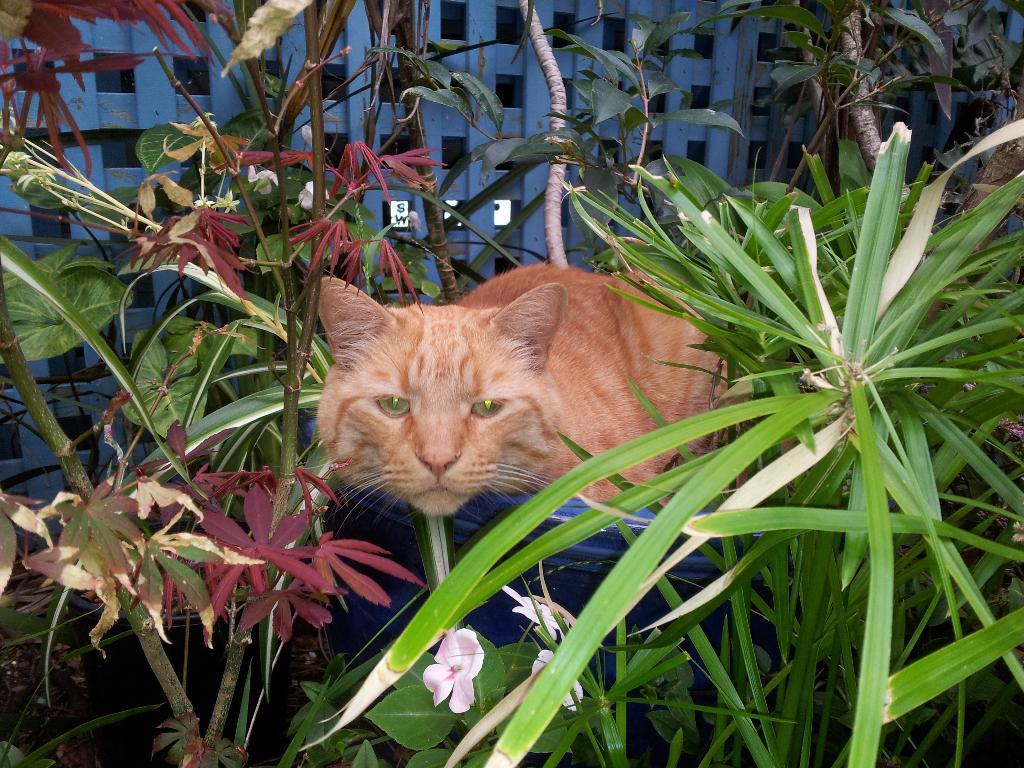What animal is present in the image? There is a cat in the image. Where is the cat located in the image? The cat is standing inside a bucket. What is the bucket placed near in the image? The bucket is placed between a group of trees. What can be seen in the background of the image? There is a wooden fence in the background of the image. What type of mine is visible in the image? There is no mine present in the image; it features a cat standing inside a bucket between a group of trees. Can you tell me how many mint leaves are on the cat's tail? There are no mint leaves present in the image, as it only features a cat standing inside a bucket. 